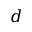Convert formula to latex. <formula><loc_0><loc_0><loc_500><loc_500>d</formula> 